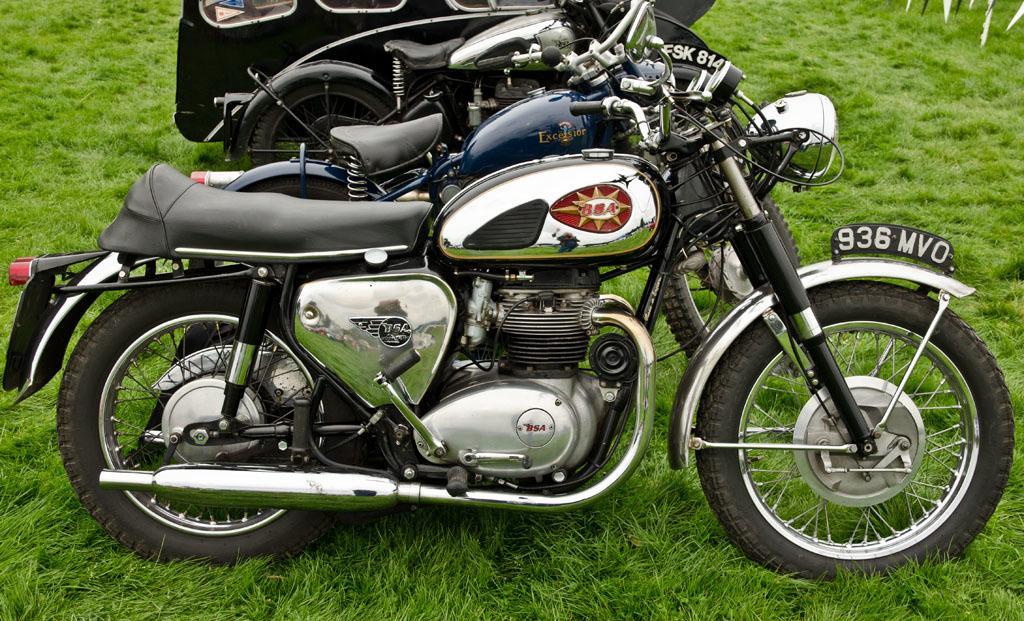Describe this image in one or two sentences. In this image we can see three bikes on the grassy surface. 